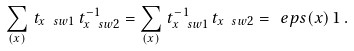Convert formula to latex. <formula><loc_0><loc_0><loc_500><loc_500>\sum _ { ( x ) } \, t _ { x \ s w 1 } \, t ^ { - 1 } _ { x \ s w 2 } = \sum _ { ( x ) } \, t ^ { - 1 } _ { x \ s w 1 } \, t _ { x \ s w 2 } = \ e p s ( x ) \, 1 \, .</formula> 